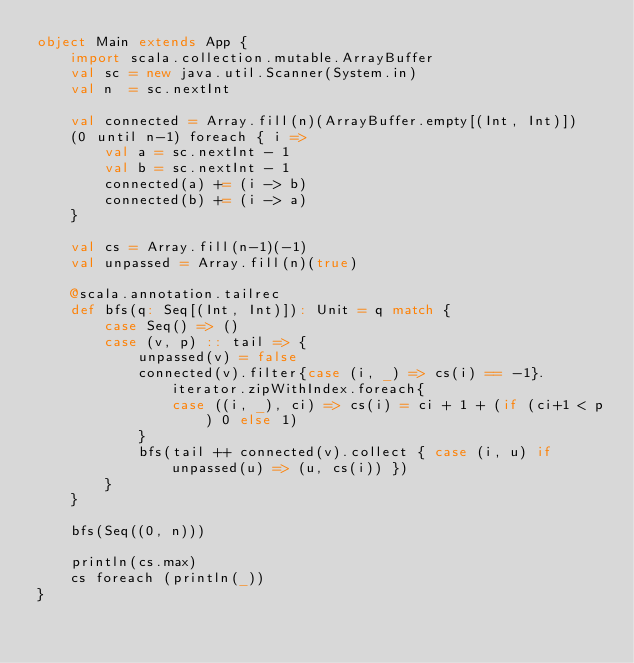<code> <loc_0><loc_0><loc_500><loc_500><_Scala_>object Main extends App {
	import scala.collection.mutable.ArrayBuffer
	val sc = new java.util.Scanner(System.in)
	val n  = sc.nextInt
	
	val connected = Array.fill(n)(ArrayBuffer.empty[(Int, Int)])
	(0 until n-1) foreach { i =>
		val a = sc.nextInt - 1
		val b = sc.nextInt - 1
		connected(a) += (i -> b)
		connected(b) += (i -> a)
	}
	
	val cs = Array.fill(n-1)(-1)
	val unpassed = Array.fill(n)(true)

	@scala.annotation.tailrec
	def bfs(q: Seq[(Int, Int)]): Unit = q match {
		case Seq() => ()
		case (v, p) :: tail => {
			unpassed(v) = false
			connected(v).filter{case (i, _) => cs(i) == -1}.iterator.zipWithIndex.foreach{
				case ((i, _), ci) => cs(i) = ci + 1 + (if (ci+1 < p) 0 else 1)
			}
			bfs(tail ++ connected(v).collect { case (i, u) if unpassed(u) => (u, cs(i)) })
		}
	}
	
	bfs(Seq((0, n)))
	
	println(cs.max)
	cs foreach (println(_))
}</code> 